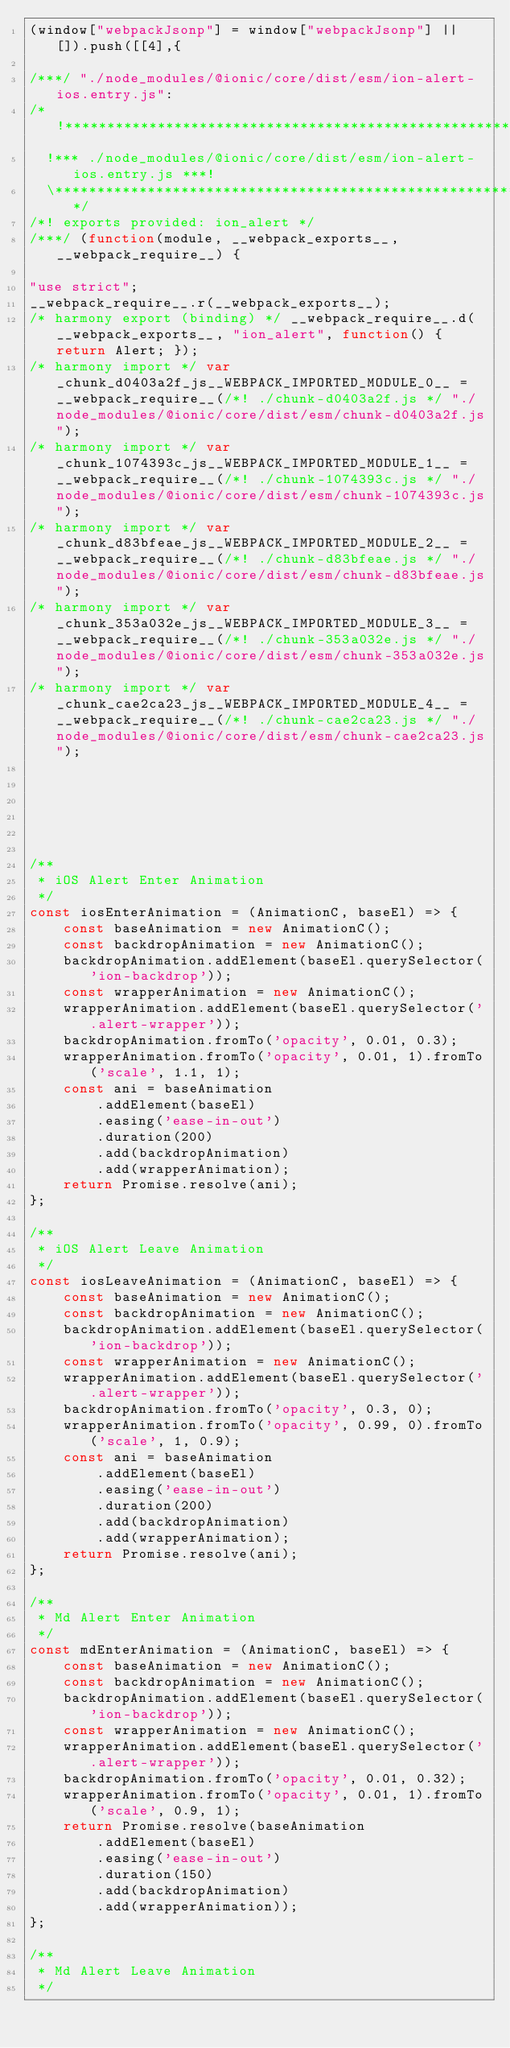Convert code to text. <code><loc_0><loc_0><loc_500><loc_500><_JavaScript_>(window["webpackJsonp"] = window["webpackJsonp"] || []).push([[4],{

/***/ "./node_modules/@ionic/core/dist/esm/ion-alert-ios.entry.js":
/*!******************************************************************!*\
  !*** ./node_modules/@ionic/core/dist/esm/ion-alert-ios.entry.js ***!
  \******************************************************************/
/*! exports provided: ion_alert */
/***/ (function(module, __webpack_exports__, __webpack_require__) {

"use strict";
__webpack_require__.r(__webpack_exports__);
/* harmony export (binding) */ __webpack_require__.d(__webpack_exports__, "ion_alert", function() { return Alert; });
/* harmony import */ var _chunk_d0403a2f_js__WEBPACK_IMPORTED_MODULE_0__ = __webpack_require__(/*! ./chunk-d0403a2f.js */ "./node_modules/@ionic/core/dist/esm/chunk-d0403a2f.js");
/* harmony import */ var _chunk_1074393c_js__WEBPACK_IMPORTED_MODULE_1__ = __webpack_require__(/*! ./chunk-1074393c.js */ "./node_modules/@ionic/core/dist/esm/chunk-1074393c.js");
/* harmony import */ var _chunk_d83bfeae_js__WEBPACK_IMPORTED_MODULE_2__ = __webpack_require__(/*! ./chunk-d83bfeae.js */ "./node_modules/@ionic/core/dist/esm/chunk-d83bfeae.js");
/* harmony import */ var _chunk_353a032e_js__WEBPACK_IMPORTED_MODULE_3__ = __webpack_require__(/*! ./chunk-353a032e.js */ "./node_modules/@ionic/core/dist/esm/chunk-353a032e.js");
/* harmony import */ var _chunk_cae2ca23_js__WEBPACK_IMPORTED_MODULE_4__ = __webpack_require__(/*! ./chunk-cae2ca23.js */ "./node_modules/@ionic/core/dist/esm/chunk-cae2ca23.js");






/**
 * iOS Alert Enter Animation
 */
const iosEnterAnimation = (AnimationC, baseEl) => {
    const baseAnimation = new AnimationC();
    const backdropAnimation = new AnimationC();
    backdropAnimation.addElement(baseEl.querySelector('ion-backdrop'));
    const wrapperAnimation = new AnimationC();
    wrapperAnimation.addElement(baseEl.querySelector('.alert-wrapper'));
    backdropAnimation.fromTo('opacity', 0.01, 0.3);
    wrapperAnimation.fromTo('opacity', 0.01, 1).fromTo('scale', 1.1, 1);
    const ani = baseAnimation
        .addElement(baseEl)
        .easing('ease-in-out')
        .duration(200)
        .add(backdropAnimation)
        .add(wrapperAnimation);
    return Promise.resolve(ani);
};

/**
 * iOS Alert Leave Animation
 */
const iosLeaveAnimation = (AnimationC, baseEl) => {
    const baseAnimation = new AnimationC();
    const backdropAnimation = new AnimationC();
    backdropAnimation.addElement(baseEl.querySelector('ion-backdrop'));
    const wrapperAnimation = new AnimationC();
    wrapperAnimation.addElement(baseEl.querySelector('.alert-wrapper'));
    backdropAnimation.fromTo('opacity', 0.3, 0);
    wrapperAnimation.fromTo('opacity', 0.99, 0).fromTo('scale', 1, 0.9);
    const ani = baseAnimation
        .addElement(baseEl)
        .easing('ease-in-out')
        .duration(200)
        .add(backdropAnimation)
        .add(wrapperAnimation);
    return Promise.resolve(ani);
};

/**
 * Md Alert Enter Animation
 */
const mdEnterAnimation = (AnimationC, baseEl) => {
    const baseAnimation = new AnimationC();
    const backdropAnimation = new AnimationC();
    backdropAnimation.addElement(baseEl.querySelector('ion-backdrop'));
    const wrapperAnimation = new AnimationC();
    wrapperAnimation.addElement(baseEl.querySelector('.alert-wrapper'));
    backdropAnimation.fromTo('opacity', 0.01, 0.32);
    wrapperAnimation.fromTo('opacity', 0.01, 1).fromTo('scale', 0.9, 1);
    return Promise.resolve(baseAnimation
        .addElement(baseEl)
        .easing('ease-in-out')
        .duration(150)
        .add(backdropAnimation)
        .add(wrapperAnimation));
};

/**
 * Md Alert Leave Animation
 */</code> 